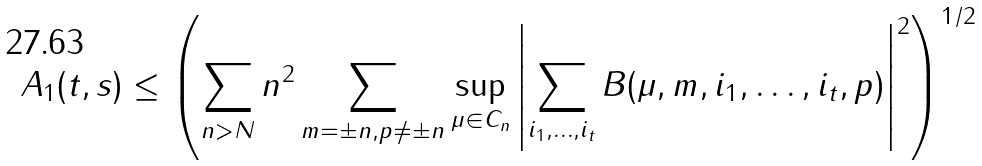Convert formula to latex. <formula><loc_0><loc_0><loc_500><loc_500>A _ { 1 } ( t , s ) \leq \left ( \sum _ { n > N } n ^ { 2 } \sum _ { m = \pm n , p \neq \pm n } \sup _ { \mu \in C _ { n } } \left | \sum _ { i _ { 1 } , \dots , i _ { t } } B ( \mu , m , i _ { 1 } , \dots , i _ { t } , p ) \right | ^ { 2 } \right ) ^ { 1 / 2 }</formula> 